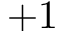Convert formula to latex. <formula><loc_0><loc_0><loc_500><loc_500>+ 1</formula> 